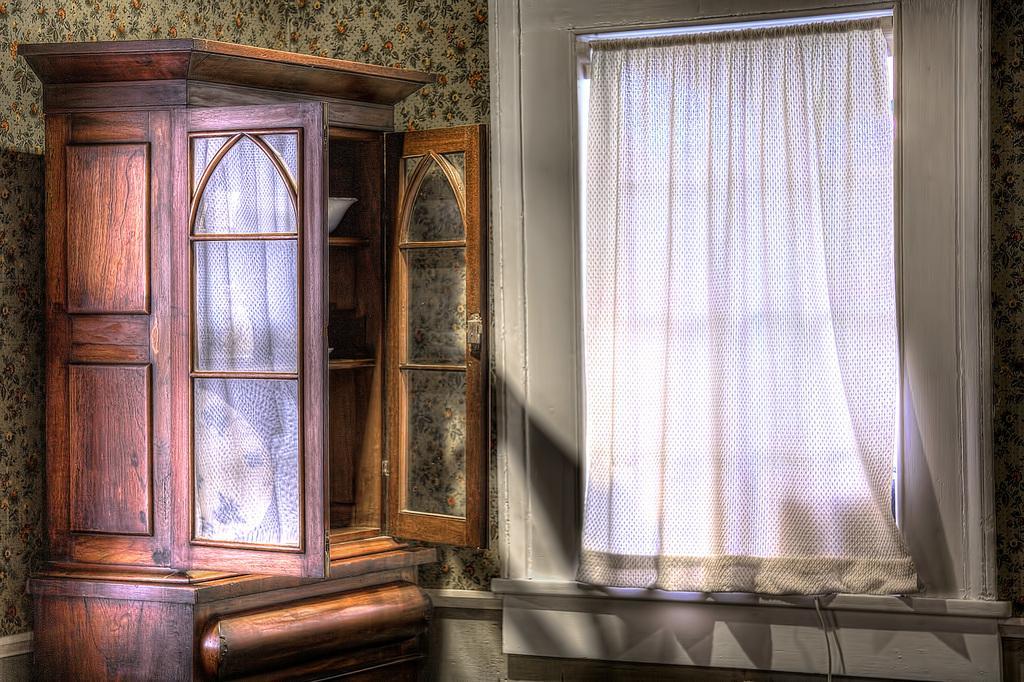How would you summarize this image in a sentence or two? In this image I see the cupboard over here which is of brown in color and I see the wall and the curtain over here which is of white in color and I see a wire over here. 